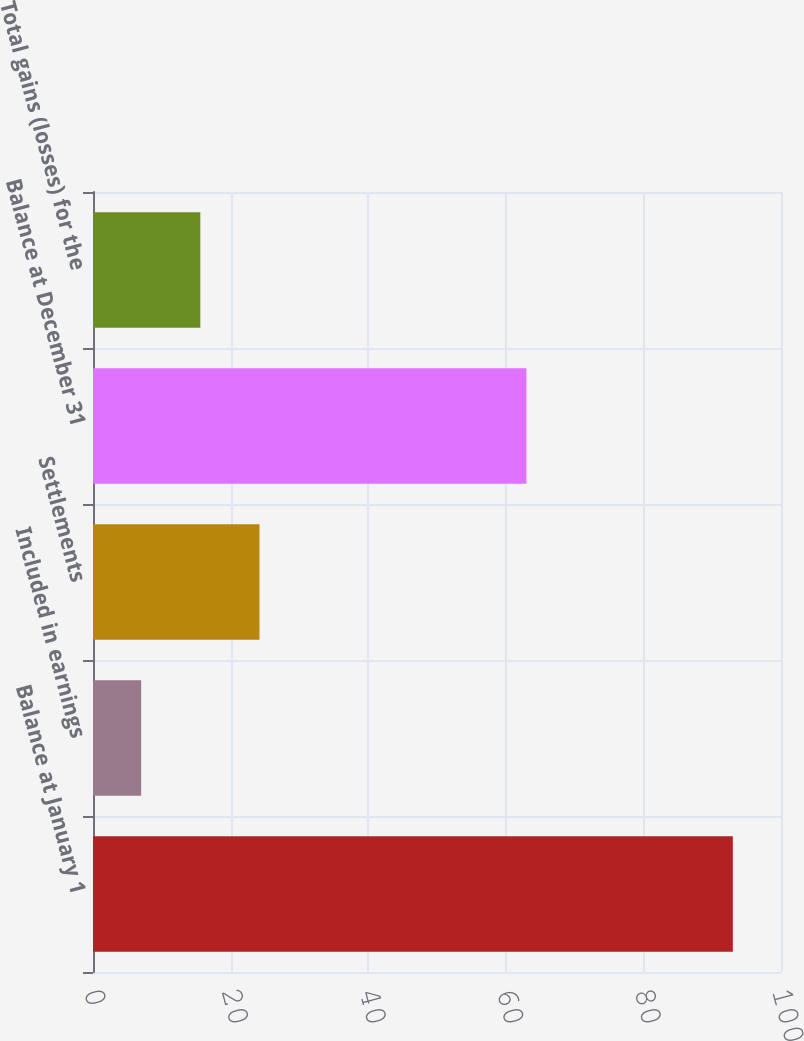Convert chart. <chart><loc_0><loc_0><loc_500><loc_500><bar_chart><fcel>Balance at January 1<fcel>Included in earnings<fcel>Settlements<fcel>Balance at December 31<fcel>Total gains (losses) for the<nl><fcel>93<fcel>7<fcel>24.2<fcel>63<fcel>15.6<nl></chart> 